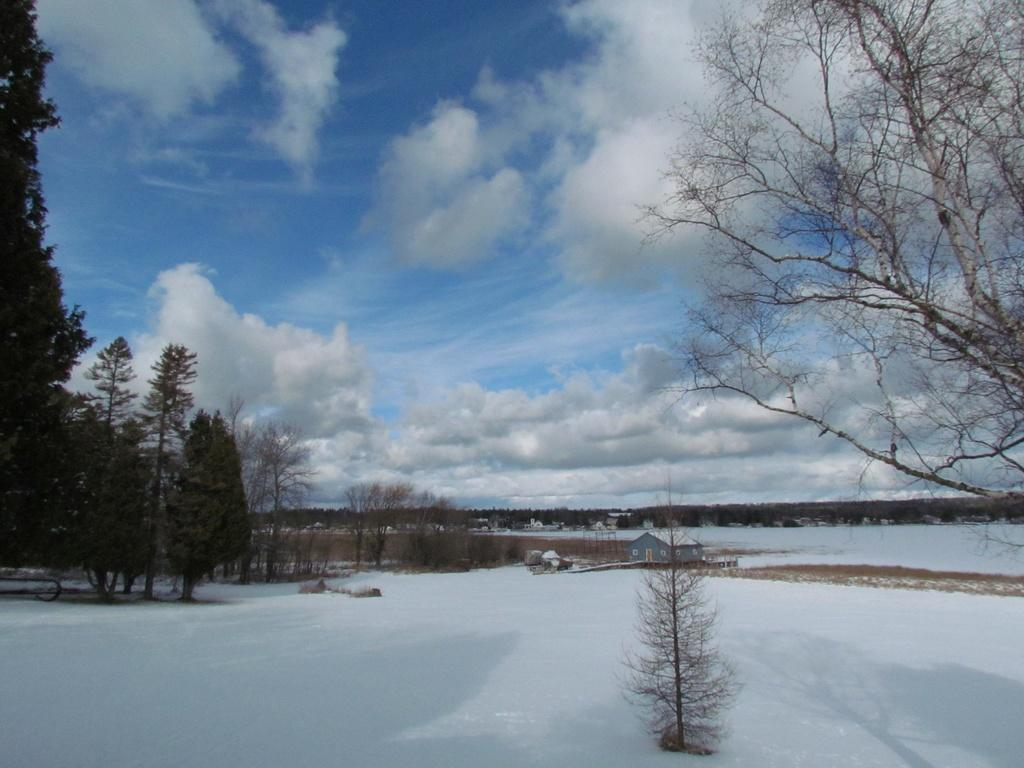What type of vegetation can be seen in the image? There are trees in the image. What is the weather like in the image? There is snow visible in the image, indicating a cold or wintry weather. What other living organism can be seen in the image? There is a plant in the image. What structure is visible in the distance? There is a house visible in the distance. What is visible in the sky in the image? The sky is visible in the image, and clouds are present. Where are the dolls playing in the image? There are no dolls present in the image. Is there a railway visible in the image? There is no railway visible in the image. 